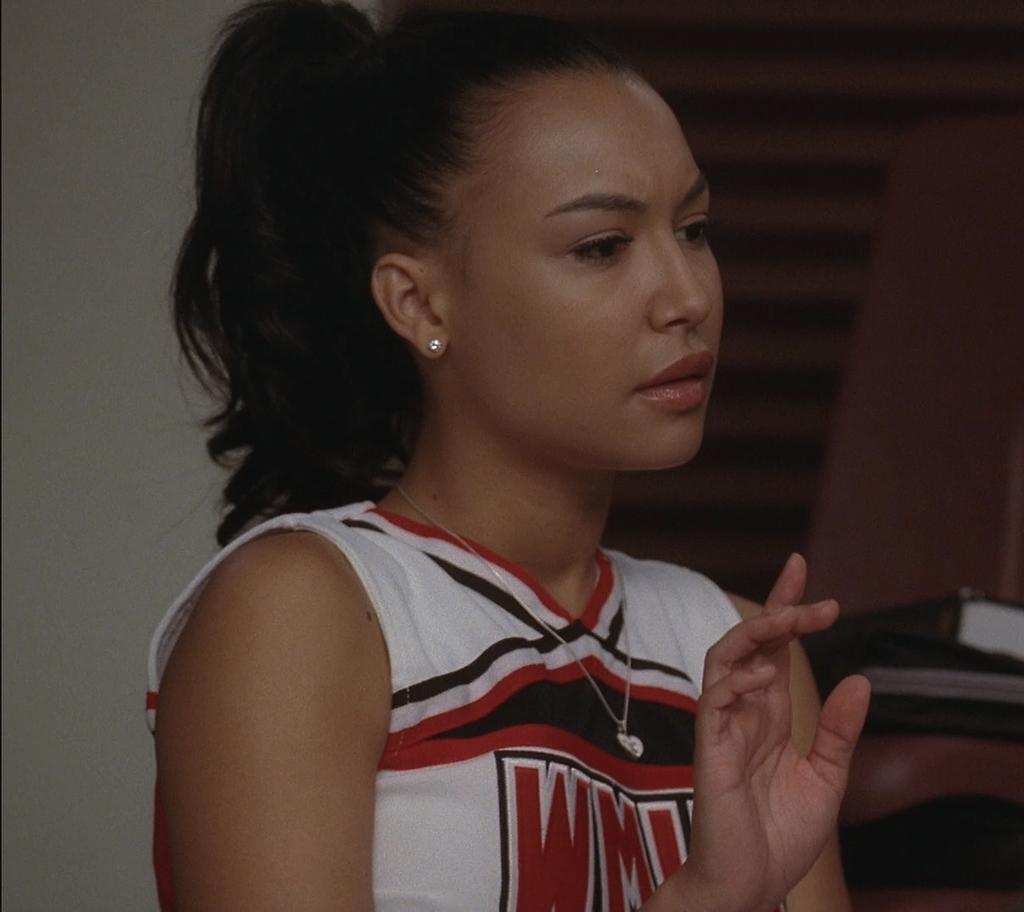<image>
Share a concise interpretation of the image provided. A young woman's cheerleader outfit has a partially displayed word which starts with WMI. 